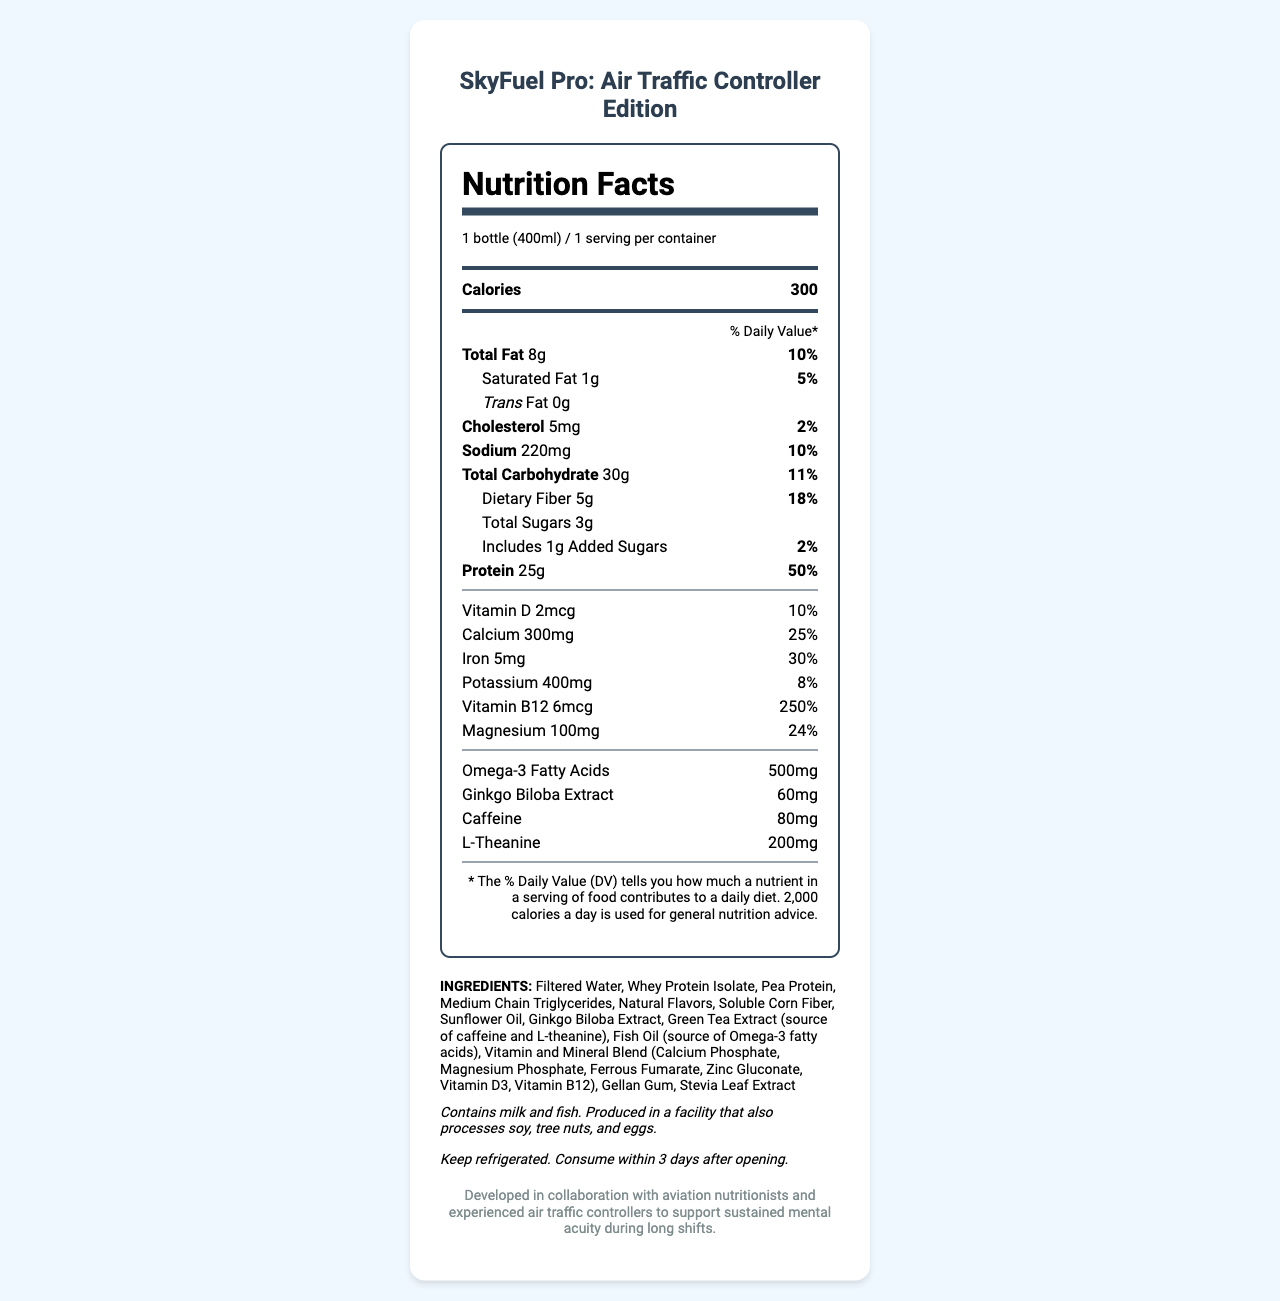what is the serving size of SkyFuel Pro? The serving size is mentioned as "1 bottle (400ml)" under the serving information.
Answer: 1 bottle (400ml) how many calories are in one serving? The calories per serving, which is one bottle, are listed as 300.
Answer: 300 how much protein is in one serving? The amount of protein per serving is listed as 25g.
Answer: 25g what is the percentage of the daily value for Vitamin B12 in one serving? The daily value percentage for Vitamin B12 is given as 250%.
Answer: 250% what are the total carbohydrates in one serving? The total carbohydrate content is listed as 30g.
Answer: 30g which of the following ingredients is NOT present in SkyFuel Pro: A. Whey Protein Isolate B. Almonds C. Fish Oil D. Pea Protein The document lists the ingredients, and almonds are not included.
Answer: B how many grams of dietary fiber are there per serving? A. 2g B. 5g C. 8g D. 12g There are 5g of dietary fiber in one serving as mentioned in the nutrient information.
Answer: B is SkyFuel Pro suitable for someone allergic to fish? The allergen information indicates that it contains fish.
Answer: No what should you do with SkyFuel Pro after opening it? The storage instructions mention to keep the product refrigerated and consume it within 3 days of opening.
Answer: Keep refrigerated. Consume within 3 days after opening. describe the main goal of SkyFuel Pro based on the document The document describes the product as being developed in collaboration with aviation nutritionists and experienced air traffic controllers to support mental sharpness during long shifts.
Answer: SkyFuel Pro is designed to support sustained mental acuity for aviation professionals, particularly air traffic controllers, by providing a balanced nutritional profile including protein, vitamins, minerals, and specific additives like Omega-3, caffeine, and L-theanine. how much saturated fat is in a serving, and what is its daily value percentage? The document lists 1g of saturated fat per serving and a daily value percentage of 5%.
Answer: 1g, 5% how much omega-3 fatty acids are in one serving? The listed amount of Omega-3 fatty acids per serving is 500mg.
Answer: 500mg can you find the expiration date of the product in the document? The document does not include any details about the expiration date of the product.
Answer: Not enough information what ingredient besides ginkgo biloba extract is included for cognitive support? Green Tea Extract, which includes caffeine and L-theanine, is listed among the ingredients and known for cognitive support.
Answer: Green Tea Extract (source of caffeine and L-theanine) what is the total amount of sugars in the product? The document lists the total sugars as 3g.
Answer: 3g how much iron is present in one serving, and what is its daily value percentage? The document states that one serving contains 5mg of iron, with a daily value percentage of 30%.
Answer: 5mg, 30% compare the daily value percentages of calcium and magnesium. Which one is higher? According to the document, the daily value percentage for calcium is 25%, which is slightly higher than that of magnesium at 24%.
Answer: Calcium is higher with 25% daily value compared to Magnesium’s 24%. how much cholesterol is in one serving? The document indicates that there are 5mg of cholesterol per serving.
Answer: 5mg what is the primary ingredient in SkyFuel Pro? The first ingredient listed is Filtered Water, indicating it is the primary ingredient.
Answer: Filtered Water 